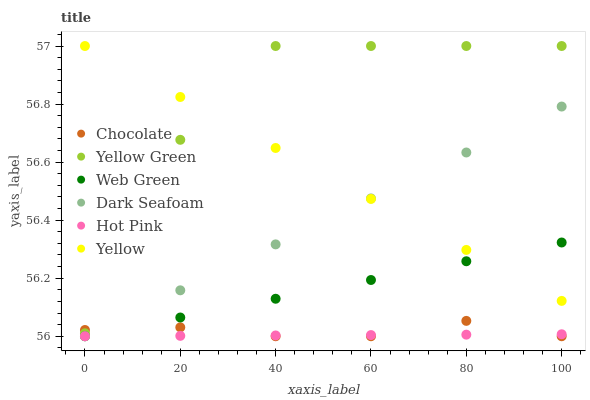Does Hot Pink have the minimum area under the curve?
Answer yes or no. Yes. Does Yellow Green have the maximum area under the curve?
Answer yes or no. Yes. Does Yellow have the minimum area under the curve?
Answer yes or no. No. Does Yellow have the maximum area under the curve?
Answer yes or no. No. Is Hot Pink the smoothest?
Answer yes or no. Yes. Is Yellow Green the roughest?
Answer yes or no. Yes. Is Yellow the smoothest?
Answer yes or no. No. Is Yellow the roughest?
Answer yes or no. No. Does Hot Pink have the lowest value?
Answer yes or no. Yes. Does Yellow have the lowest value?
Answer yes or no. No. Does Yellow have the highest value?
Answer yes or no. Yes. Does Hot Pink have the highest value?
Answer yes or no. No. Is Chocolate less than Yellow?
Answer yes or no. Yes. Is Yellow greater than Chocolate?
Answer yes or no. Yes. Does Web Green intersect Hot Pink?
Answer yes or no. Yes. Is Web Green less than Hot Pink?
Answer yes or no. No. Is Web Green greater than Hot Pink?
Answer yes or no. No. Does Chocolate intersect Yellow?
Answer yes or no. No. 